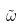Convert formula to latex. <formula><loc_0><loc_0><loc_500><loc_500>\tilde { \omega }</formula> 